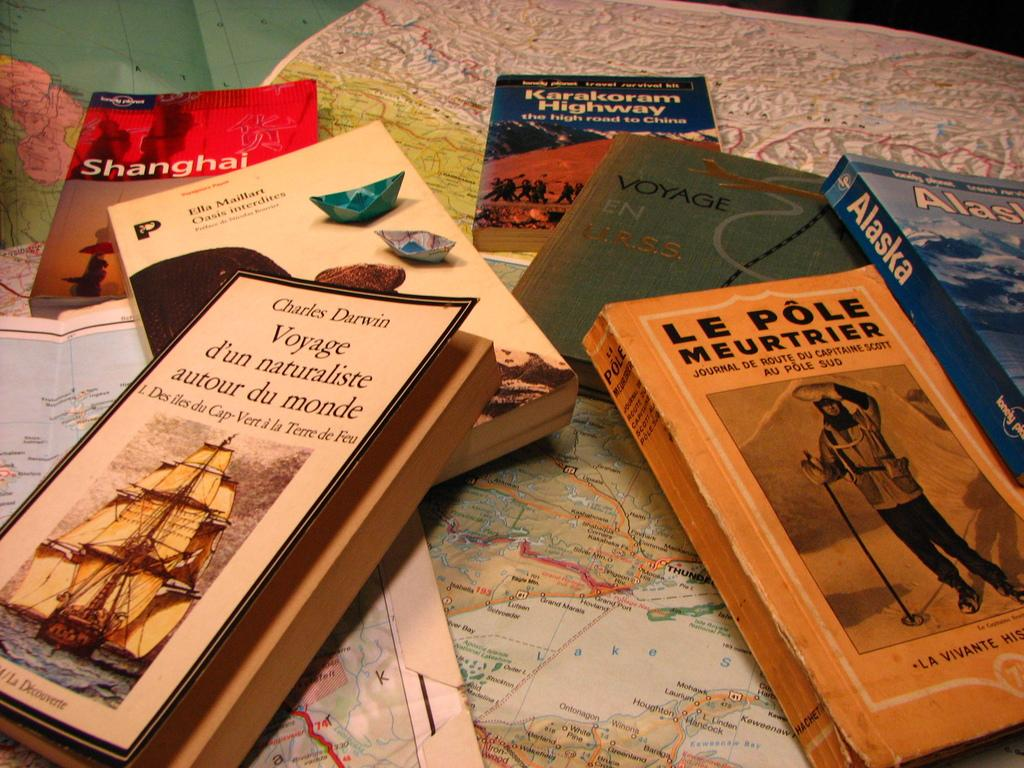Provide a one-sentence caption for the provided image. A Charles Darwin book sits in a pile with other books. 